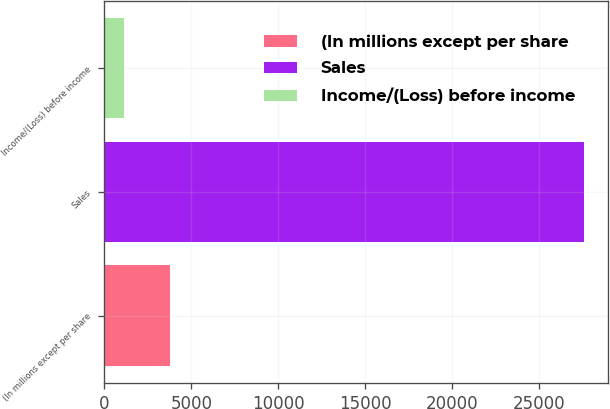Convert chart. <chart><loc_0><loc_0><loc_500><loc_500><bar_chart><fcel>(In millions except per share<fcel>Sales<fcel>Income/(Loss) before income<nl><fcel>3772.6<fcel>27592<fcel>1126<nl></chart> 